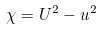<formula> <loc_0><loc_0><loc_500><loc_500>\chi = U ^ { 2 } - u ^ { 2 }</formula> 